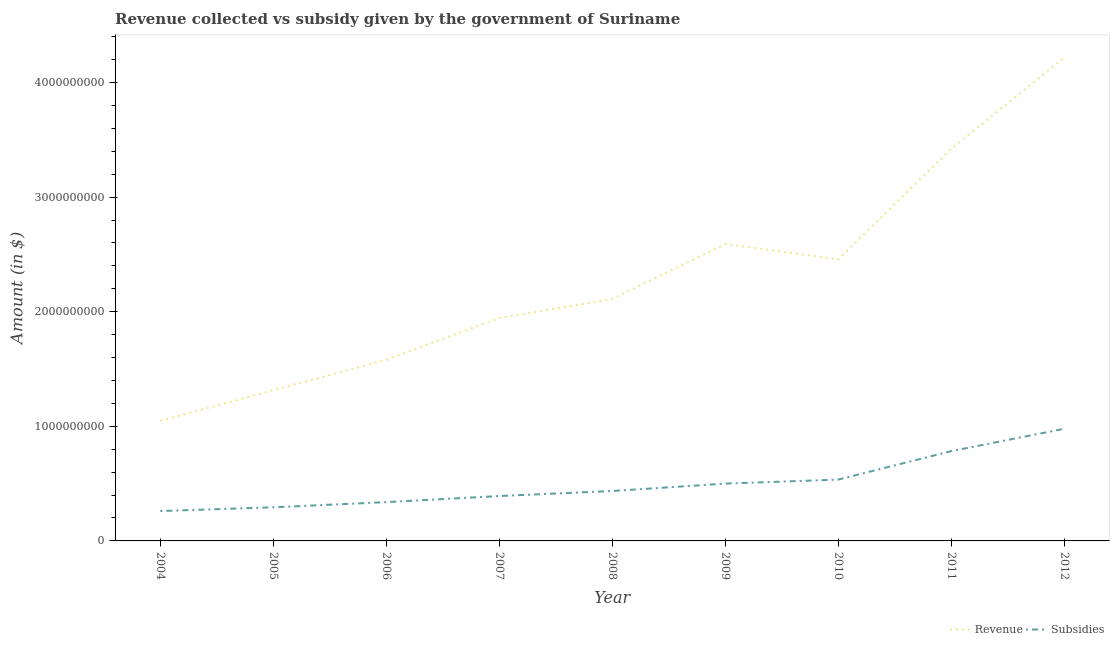Does the line corresponding to amount of revenue collected intersect with the line corresponding to amount of subsidies given?
Keep it short and to the point. No. Is the number of lines equal to the number of legend labels?
Your response must be concise. Yes. What is the amount of subsidies given in 2007?
Keep it short and to the point. 3.92e+08. Across all years, what is the maximum amount of subsidies given?
Make the answer very short. 9.79e+08. Across all years, what is the minimum amount of revenue collected?
Make the answer very short. 1.05e+09. In which year was the amount of subsidies given minimum?
Your answer should be compact. 2004. What is the total amount of revenue collected in the graph?
Offer a terse response. 2.07e+1. What is the difference between the amount of revenue collected in 2004 and that in 2012?
Your response must be concise. -3.17e+09. What is the difference between the amount of subsidies given in 2004 and the amount of revenue collected in 2007?
Your answer should be compact. -1.68e+09. What is the average amount of subsidies given per year?
Give a very brief answer. 5.02e+08. In the year 2009, what is the difference between the amount of revenue collected and amount of subsidies given?
Provide a short and direct response. 2.09e+09. What is the ratio of the amount of revenue collected in 2004 to that in 2010?
Offer a very short reply. 0.43. Is the difference between the amount of revenue collected in 2004 and 2007 greater than the difference between the amount of subsidies given in 2004 and 2007?
Offer a very short reply. No. What is the difference between the highest and the second highest amount of revenue collected?
Your answer should be compact. 7.95e+08. What is the difference between the highest and the lowest amount of revenue collected?
Your response must be concise. 3.17e+09. Is the amount of subsidies given strictly greater than the amount of revenue collected over the years?
Give a very brief answer. No. How many years are there in the graph?
Your response must be concise. 9. Are the values on the major ticks of Y-axis written in scientific E-notation?
Your answer should be very brief. No. Does the graph contain any zero values?
Your answer should be compact. No. How are the legend labels stacked?
Offer a very short reply. Horizontal. What is the title of the graph?
Keep it short and to the point. Revenue collected vs subsidy given by the government of Suriname. Does "Working capital" appear as one of the legend labels in the graph?
Make the answer very short. No. What is the label or title of the Y-axis?
Keep it short and to the point. Amount (in $). What is the Amount (in $) in Revenue in 2004?
Your answer should be compact. 1.05e+09. What is the Amount (in $) in Subsidies in 2004?
Give a very brief answer. 2.61e+08. What is the Amount (in $) in Revenue in 2005?
Make the answer very short. 1.32e+09. What is the Amount (in $) of Subsidies in 2005?
Keep it short and to the point. 2.93e+08. What is the Amount (in $) of Revenue in 2006?
Your response must be concise. 1.58e+09. What is the Amount (in $) of Subsidies in 2006?
Your answer should be compact. 3.39e+08. What is the Amount (in $) in Revenue in 2007?
Your answer should be compact. 1.94e+09. What is the Amount (in $) of Subsidies in 2007?
Make the answer very short. 3.92e+08. What is the Amount (in $) in Revenue in 2008?
Make the answer very short. 2.11e+09. What is the Amount (in $) in Subsidies in 2008?
Your answer should be compact. 4.36e+08. What is the Amount (in $) of Revenue in 2009?
Make the answer very short. 2.59e+09. What is the Amount (in $) in Subsidies in 2009?
Give a very brief answer. 5.00e+08. What is the Amount (in $) in Revenue in 2010?
Offer a very short reply. 2.46e+09. What is the Amount (in $) of Subsidies in 2010?
Provide a short and direct response. 5.35e+08. What is the Amount (in $) of Revenue in 2011?
Offer a terse response. 3.42e+09. What is the Amount (in $) of Subsidies in 2011?
Offer a terse response. 7.84e+08. What is the Amount (in $) of Revenue in 2012?
Provide a succinct answer. 4.22e+09. What is the Amount (in $) of Subsidies in 2012?
Give a very brief answer. 9.79e+08. Across all years, what is the maximum Amount (in $) of Revenue?
Give a very brief answer. 4.22e+09. Across all years, what is the maximum Amount (in $) of Subsidies?
Give a very brief answer. 9.79e+08. Across all years, what is the minimum Amount (in $) in Revenue?
Make the answer very short. 1.05e+09. Across all years, what is the minimum Amount (in $) in Subsidies?
Your response must be concise. 2.61e+08. What is the total Amount (in $) of Revenue in the graph?
Ensure brevity in your answer.  2.07e+1. What is the total Amount (in $) in Subsidies in the graph?
Make the answer very short. 4.52e+09. What is the difference between the Amount (in $) of Revenue in 2004 and that in 2005?
Give a very brief answer. -2.67e+08. What is the difference between the Amount (in $) in Subsidies in 2004 and that in 2005?
Offer a very short reply. -3.27e+07. What is the difference between the Amount (in $) of Revenue in 2004 and that in 2006?
Offer a terse response. -5.32e+08. What is the difference between the Amount (in $) in Subsidies in 2004 and that in 2006?
Your answer should be very brief. -7.80e+07. What is the difference between the Amount (in $) in Revenue in 2004 and that in 2007?
Give a very brief answer. -8.97e+08. What is the difference between the Amount (in $) of Subsidies in 2004 and that in 2007?
Your answer should be compact. -1.31e+08. What is the difference between the Amount (in $) in Revenue in 2004 and that in 2008?
Provide a succinct answer. -1.06e+09. What is the difference between the Amount (in $) in Subsidies in 2004 and that in 2008?
Your answer should be very brief. -1.75e+08. What is the difference between the Amount (in $) of Revenue in 2004 and that in 2009?
Ensure brevity in your answer.  -1.54e+09. What is the difference between the Amount (in $) of Subsidies in 2004 and that in 2009?
Make the answer very short. -2.39e+08. What is the difference between the Amount (in $) in Revenue in 2004 and that in 2010?
Your answer should be very brief. -1.41e+09. What is the difference between the Amount (in $) of Subsidies in 2004 and that in 2010?
Make the answer very short. -2.75e+08. What is the difference between the Amount (in $) of Revenue in 2004 and that in 2011?
Your answer should be compact. -2.37e+09. What is the difference between the Amount (in $) in Subsidies in 2004 and that in 2011?
Offer a very short reply. -5.23e+08. What is the difference between the Amount (in $) in Revenue in 2004 and that in 2012?
Your response must be concise. -3.17e+09. What is the difference between the Amount (in $) in Subsidies in 2004 and that in 2012?
Make the answer very short. -7.18e+08. What is the difference between the Amount (in $) in Revenue in 2005 and that in 2006?
Provide a succinct answer. -2.65e+08. What is the difference between the Amount (in $) of Subsidies in 2005 and that in 2006?
Offer a terse response. -4.53e+07. What is the difference between the Amount (in $) in Revenue in 2005 and that in 2007?
Provide a succinct answer. -6.30e+08. What is the difference between the Amount (in $) in Subsidies in 2005 and that in 2007?
Your answer should be very brief. -9.84e+07. What is the difference between the Amount (in $) of Revenue in 2005 and that in 2008?
Give a very brief answer. -7.96e+08. What is the difference between the Amount (in $) of Subsidies in 2005 and that in 2008?
Offer a terse response. -1.42e+08. What is the difference between the Amount (in $) in Revenue in 2005 and that in 2009?
Give a very brief answer. -1.28e+09. What is the difference between the Amount (in $) of Subsidies in 2005 and that in 2009?
Your answer should be compact. -2.07e+08. What is the difference between the Amount (in $) of Revenue in 2005 and that in 2010?
Your response must be concise. -1.14e+09. What is the difference between the Amount (in $) in Subsidies in 2005 and that in 2010?
Your answer should be very brief. -2.42e+08. What is the difference between the Amount (in $) of Revenue in 2005 and that in 2011?
Keep it short and to the point. -2.11e+09. What is the difference between the Amount (in $) of Subsidies in 2005 and that in 2011?
Ensure brevity in your answer.  -4.90e+08. What is the difference between the Amount (in $) in Revenue in 2005 and that in 2012?
Provide a succinct answer. -2.90e+09. What is the difference between the Amount (in $) of Subsidies in 2005 and that in 2012?
Provide a succinct answer. -6.85e+08. What is the difference between the Amount (in $) of Revenue in 2006 and that in 2007?
Make the answer very short. -3.64e+08. What is the difference between the Amount (in $) in Subsidies in 2006 and that in 2007?
Ensure brevity in your answer.  -5.32e+07. What is the difference between the Amount (in $) in Revenue in 2006 and that in 2008?
Provide a short and direct response. -5.31e+08. What is the difference between the Amount (in $) in Subsidies in 2006 and that in 2008?
Your answer should be compact. -9.70e+07. What is the difference between the Amount (in $) in Revenue in 2006 and that in 2009?
Give a very brief answer. -1.01e+09. What is the difference between the Amount (in $) of Subsidies in 2006 and that in 2009?
Give a very brief answer. -1.61e+08. What is the difference between the Amount (in $) of Revenue in 2006 and that in 2010?
Keep it short and to the point. -8.77e+08. What is the difference between the Amount (in $) in Subsidies in 2006 and that in 2010?
Your response must be concise. -1.97e+08. What is the difference between the Amount (in $) in Revenue in 2006 and that in 2011?
Offer a terse response. -1.84e+09. What is the difference between the Amount (in $) in Subsidies in 2006 and that in 2011?
Offer a terse response. -4.45e+08. What is the difference between the Amount (in $) of Revenue in 2006 and that in 2012?
Offer a terse response. -2.64e+09. What is the difference between the Amount (in $) in Subsidies in 2006 and that in 2012?
Your response must be concise. -6.40e+08. What is the difference between the Amount (in $) of Revenue in 2007 and that in 2008?
Offer a terse response. -1.66e+08. What is the difference between the Amount (in $) of Subsidies in 2007 and that in 2008?
Keep it short and to the point. -4.38e+07. What is the difference between the Amount (in $) in Revenue in 2007 and that in 2009?
Your answer should be compact. -6.46e+08. What is the difference between the Amount (in $) of Subsidies in 2007 and that in 2009?
Your answer should be compact. -1.08e+08. What is the difference between the Amount (in $) of Revenue in 2007 and that in 2010?
Offer a very short reply. -5.12e+08. What is the difference between the Amount (in $) of Subsidies in 2007 and that in 2010?
Make the answer very short. -1.43e+08. What is the difference between the Amount (in $) of Revenue in 2007 and that in 2011?
Provide a succinct answer. -1.48e+09. What is the difference between the Amount (in $) of Subsidies in 2007 and that in 2011?
Offer a very short reply. -3.92e+08. What is the difference between the Amount (in $) in Revenue in 2007 and that in 2012?
Provide a succinct answer. -2.27e+09. What is the difference between the Amount (in $) of Subsidies in 2007 and that in 2012?
Your answer should be compact. -5.87e+08. What is the difference between the Amount (in $) in Revenue in 2008 and that in 2009?
Offer a very short reply. -4.79e+08. What is the difference between the Amount (in $) of Subsidies in 2008 and that in 2009?
Your answer should be compact. -6.43e+07. What is the difference between the Amount (in $) of Revenue in 2008 and that in 2010?
Give a very brief answer. -3.46e+08. What is the difference between the Amount (in $) of Subsidies in 2008 and that in 2010?
Make the answer very short. -9.96e+07. What is the difference between the Amount (in $) in Revenue in 2008 and that in 2011?
Your answer should be compact. -1.31e+09. What is the difference between the Amount (in $) in Subsidies in 2008 and that in 2011?
Your answer should be very brief. -3.48e+08. What is the difference between the Amount (in $) in Revenue in 2008 and that in 2012?
Your answer should be compact. -2.11e+09. What is the difference between the Amount (in $) of Subsidies in 2008 and that in 2012?
Give a very brief answer. -5.43e+08. What is the difference between the Amount (in $) of Revenue in 2009 and that in 2010?
Keep it short and to the point. 1.34e+08. What is the difference between the Amount (in $) of Subsidies in 2009 and that in 2010?
Give a very brief answer. -3.52e+07. What is the difference between the Amount (in $) of Revenue in 2009 and that in 2011?
Give a very brief answer. -8.32e+08. What is the difference between the Amount (in $) of Subsidies in 2009 and that in 2011?
Make the answer very short. -2.84e+08. What is the difference between the Amount (in $) of Revenue in 2009 and that in 2012?
Make the answer very short. -1.63e+09. What is the difference between the Amount (in $) of Subsidies in 2009 and that in 2012?
Provide a succinct answer. -4.79e+08. What is the difference between the Amount (in $) in Revenue in 2010 and that in 2011?
Keep it short and to the point. -9.65e+08. What is the difference between the Amount (in $) of Subsidies in 2010 and that in 2011?
Provide a succinct answer. -2.48e+08. What is the difference between the Amount (in $) of Revenue in 2010 and that in 2012?
Your answer should be very brief. -1.76e+09. What is the difference between the Amount (in $) of Subsidies in 2010 and that in 2012?
Provide a short and direct response. -4.43e+08. What is the difference between the Amount (in $) in Revenue in 2011 and that in 2012?
Give a very brief answer. -7.95e+08. What is the difference between the Amount (in $) in Subsidies in 2011 and that in 2012?
Offer a very short reply. -1.95e+08. What is the difference between the Amount (in $) of Revenue in 2004 and the Amount (in $) of Subsidies in 2005?
Offer a very short reply. 7.55e+08. What is the difference between the Amount (in $) in Revenue in 2004 and the Amount (in $) in Subsidies in 2006?
Make the answer very short. 7.10e+08. What is the difference between the Amount (in $) in Revenue in 2004 and the Amount (in $) in Subsidies in 2007?
Ensure brevity in your answer.  6.56e+08. What is the difference between the Amount (in $) in Revenue in 2004 and the Amount (in $) in Subsidies in 2008?
Your answer should be very brief. 6.13e+08. What is the difference between the Amount (in $) in Revenue in 2004 and the Amount (in $) in Subsidies in 2009?
Offer a very short reply. 5.48e+08. What is the difference between the Amount (in $) in Revenue in 2004 and the Amount (in $) in Subsidies in 2010?
Ensure brevity in your answer.  5.13e+08. What is the difference between the Amount (in $) of Revenue in 2004 and the Amount (in $) of Subsidies in 2011?
Offer a very short reply. 2.65e+08. What is the difference between the Amount (in $) of Revenue in 2004 and the Amount (in $) of Subsidies in 2012?
Your response must be concise. 6.96e+07. What is the difference between the Amount (in $) of Revenue in 2005 and the Amount (in $) of Subsidies in 2006?
Your answer should be compact. 9.76e+08. What is the difference between the Amount (in $) in Revenue in 2005 and the Amount (in $) in Subsidies in 2007?
Ensure brevity in your answer.  9.23e+08. What is the difference between the Amount (in $) of Revenue in 2005 and the Amount (in $) of Subsidies in 2008?
Provide a succinct answer. 8.79e+08. What is the difference between the Amount (in $) in Revenue in 2005 and the Amount (in $) in Subsidies in 2009?
Your answer should be very brief. 8.15e+08. What is the difference between the Amount (in $) in Revenue in 2005 and the Amount (in $) in Subsidies in 2010?
Make the answer very short. 7.80e+08. What is the difference between the Amount (in $) of Revenue in 2005 and the Amount (in $) of Subsidies in 2011?
Keep it short and to the point. 5.31e+08. What is the difference between the Amount (in $) of Revenue in 2005 and the Amount (in $) of Subsidies in 2012?
Ensure brevity in your answer.  3.36e+08. What is the difference between the Amount (in $) of Revenue in 2006 and the Amount (in $) of Subsidies in 2007?
Provide a succinct answer. 1.19e+09. What is the difference between the Amount (in $) of Revenue in 2006 and the Amount (in $) of Subsidies in 2008?
Offer a very short reply. 1.14e+09. What is the difference between the Amount (in $) of Revenue in 2006 and the Amount (in $) of Subsidies in 2009?
Ensure brevity in your answer.  1.08e+09. What is the difference between the Amount (in $) in Revenue in 2006 and the Amount (in $) in Subsidies in 2010?
Give a very brief answer. 1.05e+09. What is the difference between the Amount (in $) of Revenue in 2006 and the Amount (in $) of Subsidies in 2011?
Keep it short and to the point. 7.97e+08. What is the difference between the Amount (in $) of Revenue in 2006 and the Amount (in $) of Subsidies in 2012?
Offer a terse response. 6.02e+08. What is the difference between the Amount (in $) of Revenue in 2007 and the Amount (in $) of Subsidies in 2008?
Your answer should be compact. 1.51e+09. What is the difference between the Amount (in $) in Revenue in 2007 and the Amount (in $) in Subsidies in 2009?
Offer a terse response. 1.44e+09. What is the difference between the Amount (in $) in Revenue in 2007 and the Amount (in $) in Subsidies in 2010?
Offer a very short reply. 1.41e+09. What is the difference between the Amount (in $) in Revenue in 2007 and the Amount (in $) in Subsidies in 2011?
Offer a very short reply. 1.16e+09. What is the difference between the Amount (in $) in Revenue in 2007 and the Amount (in $) in Subsidies in 2012?
Your answer should be compact. 9.66e+08. What is the difference between the Amount (in $) in Revenue in 2008 and the Amount (in $) in Subsidies in 2009?
Your answer should be very brief. 1.61e+09. What is the difference between the Amount (in $) in Revenue in 2008 and the Amount (in $) in Subsidies in 2010?
Offer a terse response. 1.58e+09. What is the difference between the Amount (in $) in Revenue in 2008 and the Amount (in $) in Subsidies in 2011?
Provide a succinct answer. 1.33e+09. What is the difference between the Amount (in $) in Revenue in 2008 and the Amount (in $) in Subsidies in 2012?
Your response must be concise. 1.13e+09. What is the difference between the Amount (in $) of Revenue in 2009 and the Amount (in $) of Subsidies in 2010?
Your response must be concise. 2.06e+09. What is the difference between the Amount (in $) in Revenue in 2009 and the Amount (in $) in Subsidies in 2011?
Provide a short and direct response. 1.81e+09. What is the difference between the Amount (in $) in Revenue in 2009 and the Amount (in $) in Subsidies in 2012?
Offer a very short reply. 1.61e+09. What is the difference between the Amount (in $) of Revenue in 2010 and the Amount (in $) of Subsidies in 2011?
Keep it short and to the point. 1.67e+09. What is the difference between the Amount (in $) of Revenue in 2010 and the Amount (in $) of Subsidies in 2012?
Your answer should be very brief. 1.48e+09. What is the difference between the Amount (in $) of Revenue in 2011 and the Amount (in $) of Subsidies in 2012?
Offer a terse response. 2.44e+09. What is the average Amount (in $) of Revenue per year?
Your response must be concise. 2.30e+09. What is the average Amount (in $) of Subsidies per year?
Your response must be concise. 5.02e+08. In the year 2004, what is the difference between the Amount (in $) in Revenue and Amount (in $) in Subsidies?
Your answer should be compact. 7.88e+08. In the year 2005, what is the difference between the Amount (in $) of Revenue and Amount (in $) of Subsidies?
Provide a short and direct response. 1.02e+09. In the year 2006, what is the difference between the Amount (in $) of Revenue and Amount (in $) of Subsidies?
Ensure brevity in your answer.  1.24e+09. In the year 2007, what is the difference between the Amount (in $) of Revenue and Amount (in $) of Subsidies?
Your response must be concise. 1.55e+09. In the year 2008, what is the difference between the Amount (in $) of Revenue and Amount (in $) of Subsidies?
Provide a succinct answer. 1.68e+09. In the year 2009, what is the difference between the Amount (in $) in Revenue and Amount (in $) in Subsidies?
Keep it short and to the point. 2.09e+09. In the year 2010, what is the difference between the Amount (in $) of Revenue and Amount (in $) of Subsidies?
Your answer should be very brief. 1.92e+09. In the year 2011, what is the difference between the Amount (in $) of Revenue and Amount (in $) of Subsidies?
Give a very brief answer. 2.64e+09. In the year 2012, what is the difference between the Amount (in $) of Revenue and Amount (in $) of Subsidies?
Give a very brief answer. 3.24e+09. What is the ratio of the Amount (in $) of Revenue in 2004 to that in 2005?
Ensure brevity in your answer.  0.8. What is the ratio of the Amount (in $) in Subsidies in 2004 to that in 2005?
Offer a terse response. 0.89. What is the ratio of the Amount (in $) in Revenue in 2004 to that in 2006?
Ensure brevity in your answer.  0.66. What is the ratio of the Amount (in $) in Subsidies in 2004 to that in 2006?
Offer a terse response. 0.77. What is the ratio of the Amount (in $) of Revenue in 2004 to that in 2007?
Ensure brevity in your answer.  0.54. What is the ratio of the Amount (in $) of Subsidies in 2004 to that in 2007?
Keep it short and to the point. 0.67. What is the ratio of the Amount (in $) of Revenue in 2004 to that in 2008?
Your answer should be very brief. 0.5. What is the ratio of the Amount (in $) in Subsidies in 2004 to that in 2008?
Give a very brief answer. 0.6. What is the ratio of the Amount (in $) in Revenue in 2004 to that in 2009?
Keep it short and to the point. 0.4. What is the ratio of the Amount (in $) of Subsidies in 2004 to that in 2009?
Offer a very short reply. 0.52. What is the ratio of the Amount (in $) in Revenue in 2004 to that in 2010?
Offer a very short reply. 0.43. What is the ratio of the Amount (in $) in Subsidies in 2004 to that in 2010?
Provide a short and direct response. 0.49. What is the ratio of the Amount (in $) of Revenue in 2004 to that in 2011?
Your response must be concise. 0.31. What is the ratio of the Amount (in $) of Subsidies in 2004 to that in 2011?
Provide a short and direct response. 0.33. What is the ratio of the Amount (in $) of Revenue in 2004 to that in 2012?
Provide a succinct answer. 0.25. What is the ratio of the Amount (in $) in Subsidies in 2004 to that in 2012?
Offer a very short reply. 0.27. What is the ratio of the Amount (in $) in Revenue in 2005 to that in 2006?
Provide a succinct answer. 0.83. What is the ratio of the Amount (in $) of Subsidies in 2005 to that in 2006?
Make the answer very short. 0.87. What is the ratio of the Amount (in $) in Revenue in 2005 to that in 2007?
Offer a terse response. 0.68. What is the ratio of the Amount (in $) in Subsidies in 2005 to that in 2007?
Ensure brevity in your answer.  0.75. What is the ratio of the Amount (in $) in Revenue in 2005 to that in 2008?
Your response must be concise. 0.62. What is the ratio of the Amount (in $) of Subsidies in 2005 to that in 2008?
Give a very brief answer. 0.67. What is the ratio of the Amount (in $) in Revenue in 2005 to that in 2009?
Make the answer very short. 0.51. What is the ratio of the Amount (in $) of Subsidies in 2005 to that in 2009?
Make the answer very short. 0.59. What is the ratio of the Amount (in $) in Revenue in 2005 to that in 2010?
Give a very brief answer. 0.54. What is the ratio of the Amount (in $) of Subsidies in 2005 to that in 2010?
Give a very brief answer. 0.55. What is the ratio of the Amount (in $) of Revenue in 2005 to that in 2011?
Ensure brevity in your answer.  0.38. What is the ratio of the Amount (in $) in Subsidies in 2005 to that in 2011?
Provide a succinct answer. 0.37. What is the ratio of the Amount (in $) of Revenue in 2005 to that in 2012?
Give a very brief answer. 0.31. What is the ratio of the Amount (in $) in Subsidies in 2005 to that in 2012?
Keep it short and to the point. 0.3. What is the ratio of the Amount (in $) in Revenue in 2006 to that in 2007?
Ensure brevity in your answer.  0.81. What is the ratio of the Amount (in $) of Subsidies in 2006 to that in 2007?
Your response must be concise. 0.86. What is the ratio of the Amount (in $) in Revenue in 2006 to that in 2008?
Make the answer very short. 0.75. What is the ratio of the Amount (in $) in Subsidies in 2006 to that in 2008?
Offer a very short reply. 0.78. What is the ratio of the Amount (in $) of Revenue in 2006 to that in 2009?
Your answer should be very brief. 0.61. What is the ratio of the Amount (in $) of Subsidies in 2006 to that in 2009?
Provide a succinct answer. 0.68. What is the ratio of the Amount (in $) in Revenue in 2006 to that in 2010?
Ensure brevity in your answer.  0.64. What is the ratio of the Amount (in $) in Subsidies in 2006 to that in 2010?
Make the answer very short. 0.63. What is the ratio of the Amount (in $) in Revenue in 2006 to that in 2011?
Your response must be concise. 0.46. What is the ratio of the Amount (in $) in Subsidies in 2006 to that in 2011?
Keep it short and to the point. 0.43. What is the ratio of the Amount (in $) in Revenue in 2006 to that in 2012?
Offer a terse response. 0.37. What is the ratio of the Amount (in $) in Subsidies in 2006 to that in 2012?
Provide a short and direct response. 0.35. What is the ratio of the Amount (in $) in Revenue in 2007 to that in 2008?
Offer a terse response. 0.92. What is the ratio of the Amount (in $) in Subsidies in 2007 to that in 2008?
Your response must be concise. 0.9. What is the ratio of the Amount (in $) of Revenue in 2007 to that in 2009?
Offer a terse response. 0.75. What is the ratio of the Amount (in $) in Subsidies in 2007 to that in 2009?
Your answer should be compact. 0.78. What is the ratio of the Amount (in $) in Revenue in 2007 to that in 2010?
Give a very brief answer. 0.79. What is the ratio of the Amount (in $) in Subsidies in 2007 to that in 2010?
Offer a terse response. 0.73. What is the ratio of the Amount (in $) of Revenue in 2007 to that in 2011?
Provide a succinct answer. 0.57. What is the ratio of the Amount (in $) in Subsidies in 2007 to that in 2011?
Your answer should be compact. 0.5. What is the ratio of the Amount (in $) of Revenue in 2007 to that in 2012?
Your answer should be compact. 0.46. What is the ratio of the Amount (in $) of Subsidies in 2007 to that in 2012?
Make the answer very short. 0.4. What is the ratio of the Amount (in $) in Revenue in 2008 to that in 2009?
Make the answer very short. 0.81. What is the ratio of the Amount (in $) of Subsidies in 2008 to that in 2009?
Make the answer very short. 0.87. What is the ratio of the Amount (in $) of Revenue in 2008 to that in 2010?
Make the answer very short. 0.86. What is the ratio of the Amount (in $) of Subsidies in 2008 to that in 2010?
Make the answer very short. 0.81. What is the ratio of the Amount (in $) in Revenue in 2008 to that in 2011?
Provide a succinct answer. 0.62. What is the ratio of the Amount (in $) of Subsidies in 2008 to that in 2011?
Keep it short and to the point. 0.56. What is the ratio of the Amount (in $) in Revenue in 2008 to that in 2012?
Your response must be concise. 0.5. What is the ratio of the Amount (in $) in Subsidies in 2008 to that in 2012?
Your answer should be compact. 0.45. What is the ratio of the Amount (in $) of Revenue in 2009 to that in 2010?
Ensure brevity in your answer.  1.05. What is the ratio of the Amount (in $) in Subsidies in 2009 to that in 2010?
Your answer should be compact. 0.93. What is the ratio of the Amount (in $) of Revenue in 2009 to that in 2011?
Your response must be concise. 0.76. What is the ratio of the Amount (in $) of Subsidies in 2009 to that in 2011?
Give a very brief answer. 0.64. What is the ratio of the Amount (in $) in Revenue in 2009 to that in 2012?
Offer a very short reply. 0.61. What is the ratio of the Amount (in $) in Subsidies in 2009 to that in 2012?
Offer a very short reply. 0.51. What is the ratio of the Amount (in $) of Revenue in 2010 to that in 2011?
Offer a terse response. 0.72. What is the ratio of the Amount (in $) in Subsidies in 2010 to that in 2011?
Offer a terse response. 0.68. What is the ratio of the Amount (in $) in Revenue in 2010 to that in 2012?
Offer a terse response. 0.58. What is the ratio of the Amount (in $) in Subsidies in 2010 to that in 2012?
Offer a very short reply. 0.55. What is the ratio of the Amount (in $) of Revenue in 2011 to that in 2012?
Give a very brief answer. 0.81. What is the ratio of the Amount (in $) in Subsidies in 2011 to that in 2012?
Your answer should be very brief. 0.8. What is the difference between the highest and the second highest Amount (in $) of Revenue?
Make the answer very short. 7.95e+08. What is the difference between the highest and the second highest Amount (in $) of Subsidies?
Offer a terse response. 1.95e+08. What is the difference between the highest and the lowest Amount (in $) in Revenue?
Ensure brevity in your answer.  3.17e+09. What is the difference between the highest and the lowest Amount (in $) of Subsidies?
Provide a succinct answer. 7.18e+08. 